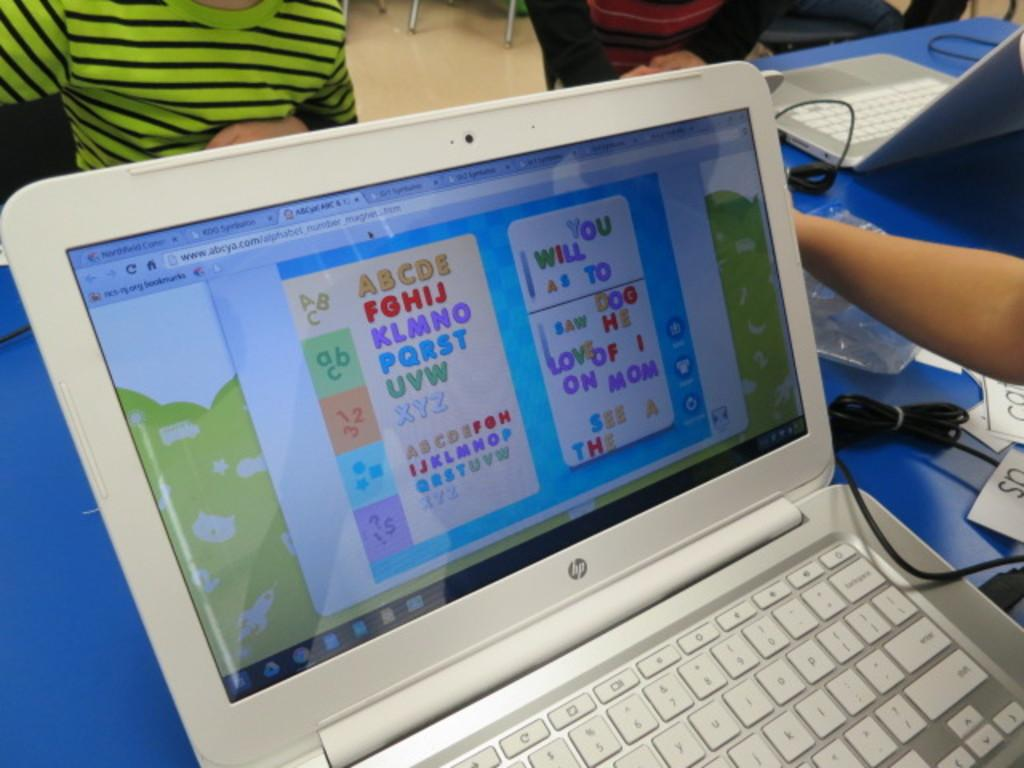<image>
Create a compact narrative representing the image presented. The alphabet is shown with the word mom spelled out. 